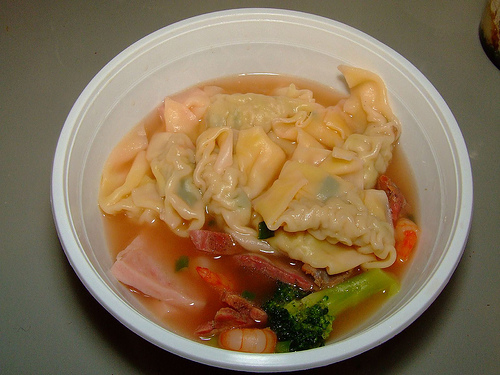<image>
Can you confirm if the soup is next to the bowl? No. The soup is not positioned next to the bowl. They are located in different areas of the scene. 